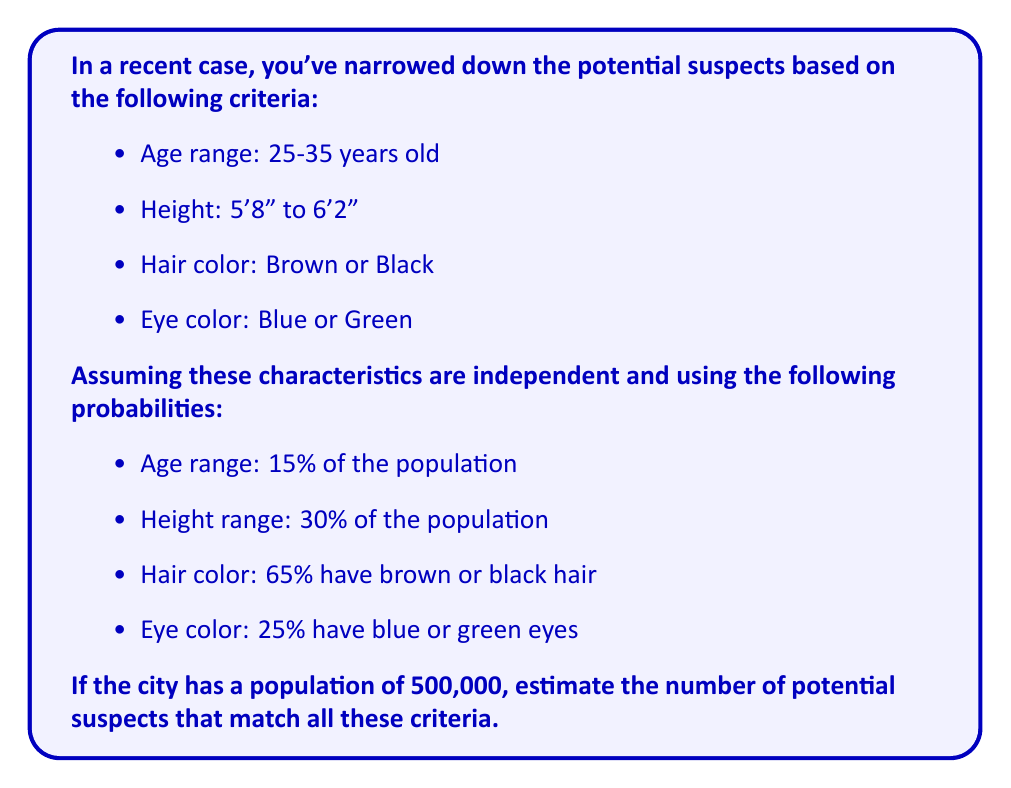Could you help me with this problem? To solve this problem, we'll use the multiplication principle of probability, assuming independence of characteristics:

1. Calculate the probability of a person matching all criteria:
   $P(\text{all criteria}) = P(\text{age}) \times P(\text{height}) \times P(\text{hair}) \times P(\text{eye})$
   $P(\text{all criteria}) = 0.15 \times 0.30 \times 0.65 \times 0.25$
   $P(\text{all criteria}) = 0.0073125$

2. Estimate the number of suspects:
   $\text{Number of suspects} = \text{Total population} \times P(\text{all criteria})$
   $\text{Number of suspects} = 500,000 \times 0.0073125$
   $\text{Number of suspects} = 3,656.25$

3. Round to the nearest whole number:
   $\text{Number of suspects} \approx 3,656$
Answer: 3,656 potential suspects 